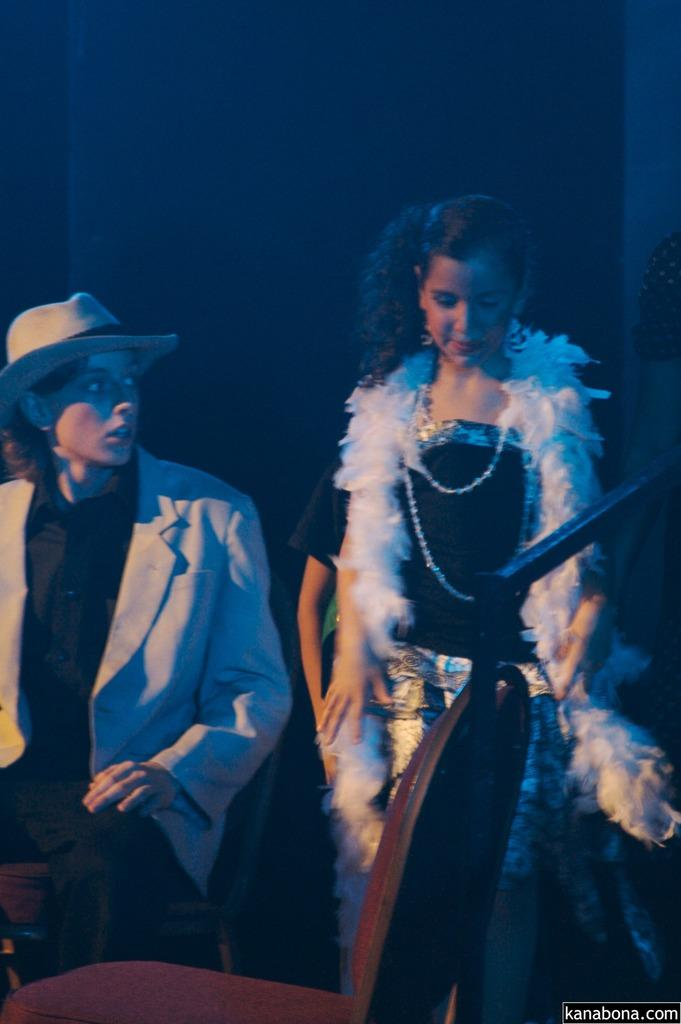Who is present in the image? There is a woman and a person wearing a suit in the image. What is the person wearing a suit doing in the image? The person is sitting on a chair. Can you describe the person's attire? The person is wearing a suit and a cap. What can be seen in the background of the image? There is a wall in the background of the image. What is the seating arrangement in the image? There is a chair in front of the woman and the person. What type of stamp can be seen on the notebook in the image? There is no notebook or stamp present in the image. 